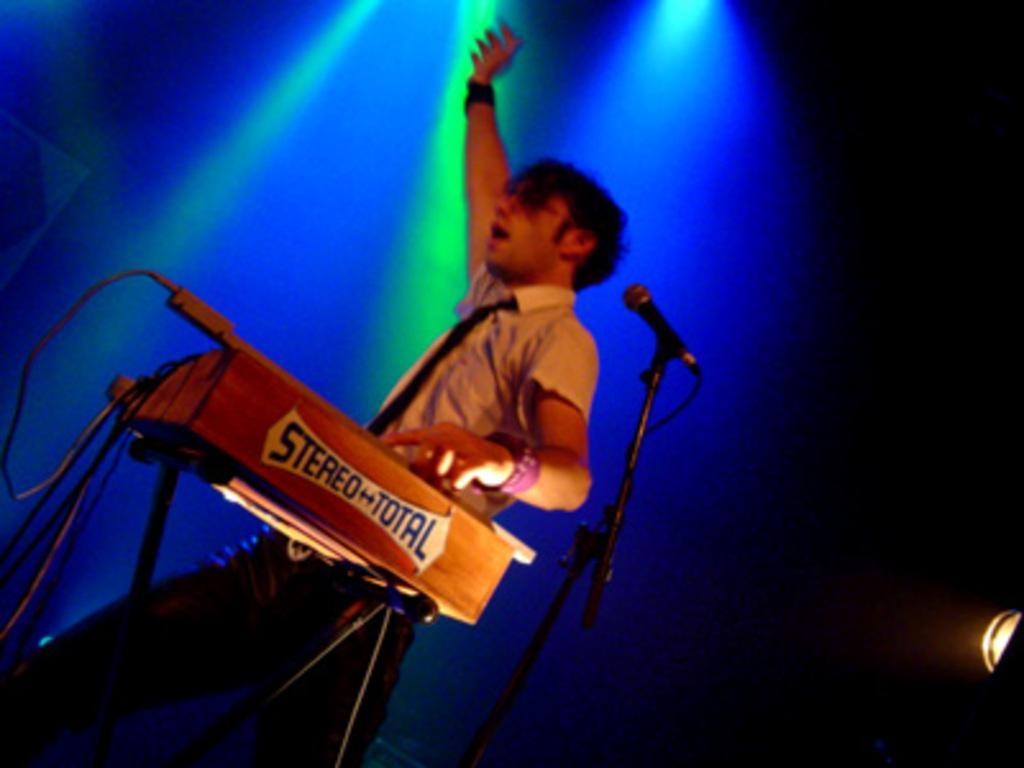Can you describe this image briefly? In this image I can see there is a man standing and playing a musical instrument and there is a microphone and lights attached to the ceiling. 